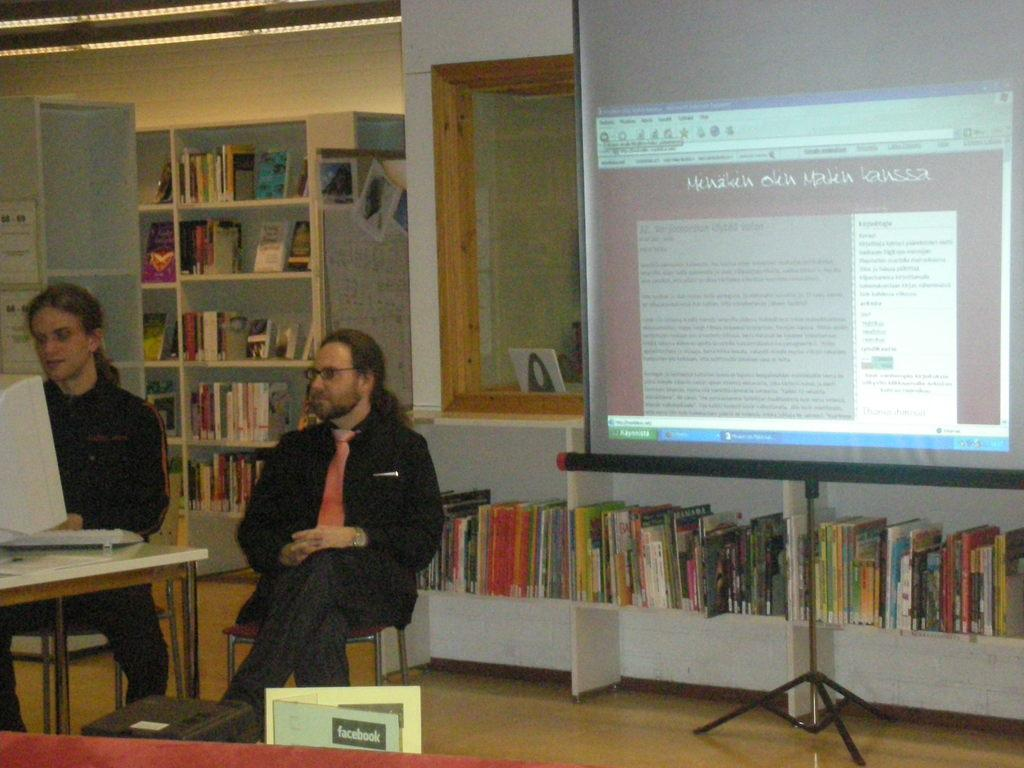How many people are in the image? There are two men in the image. What are the men doing in the image? The men are sitting on chairs. What is in front of the men? There is a monitor in front of the men. What can be seen in the background of the image? There are books arranged on a shelf in the background. What is the large, flat surface in the image? There is a projector screen in the image. How much money is being exchanged between the men in the image? There is no indication of money being exchanged in the image. What type of plough is being used in the image? There is no plough present in the image. 